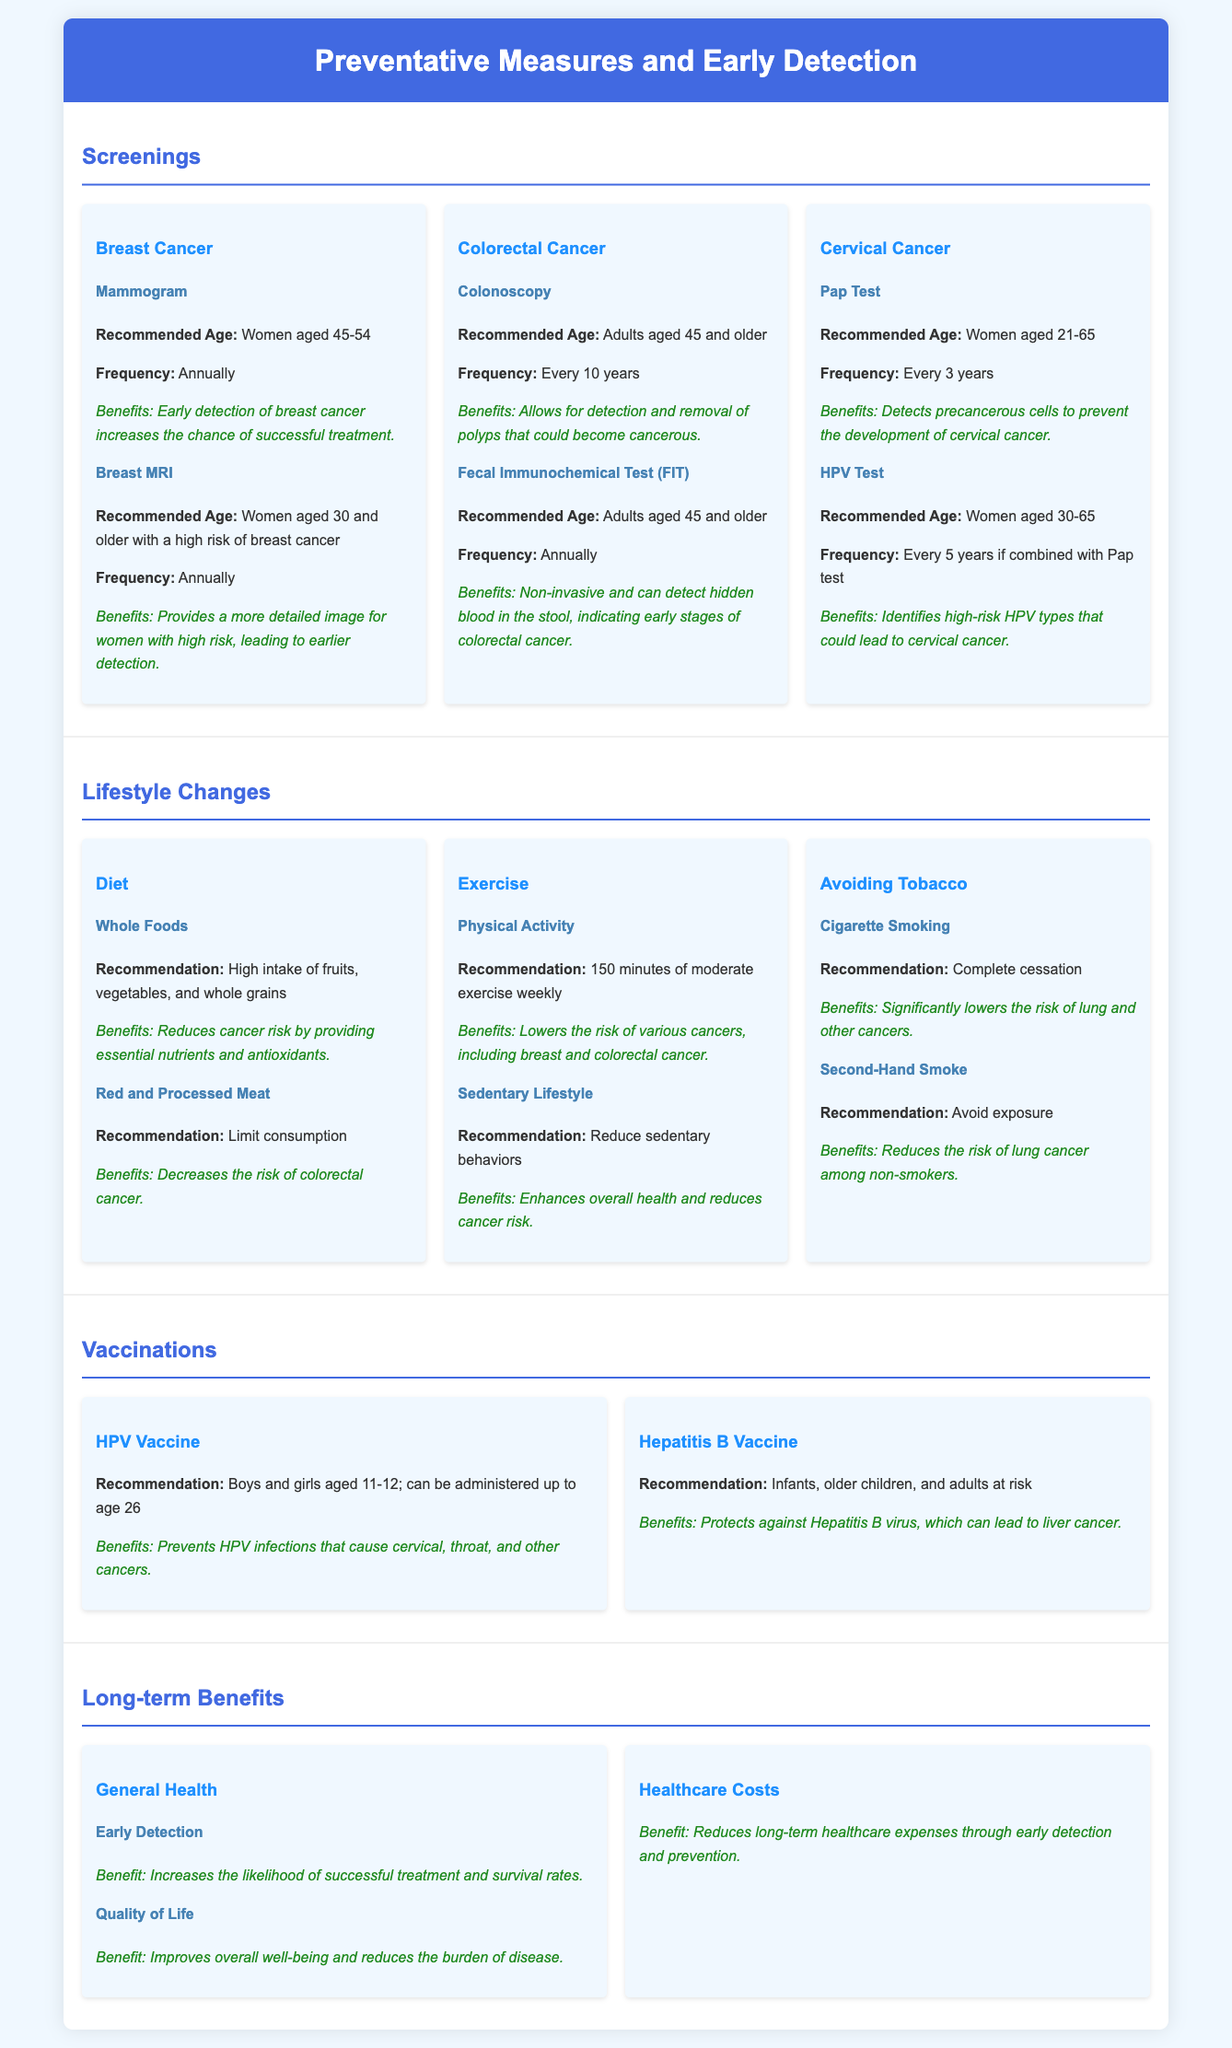What is the recommended age for a mammogram? The document states that women aged 45-54 should have a mammogram.
Answer: Women aged 45-54 How often should adults aged 45 and older have a colonoscopy? According to the document, adults aged 45 and older should have a colonoscopy every 10 years.
Answer: Every 10 years What is the benefit of early detection mentioned in the long-term benefits section? The benefit of early detection is an increased likelihood of successful treatment and survival rates.
Answer: Increased likelihood of successful treatment and survival rates What lifestyle change is recommended to limit the risk of colorectal cancer? The document advises to limit the consumption of red and processed meat to reduce the risk of colorectal cancer.
Answer: Limit consumption of red and processed meat What vaccination is recommended for boys and girls aged 11-12? The document recommends the HPV vaccine for boys and girls aged 11-12.
Answer: HPV vaccine What is stated as the frequency for a Pap test? The document mentions that women aged 21-65 should have a Pap test every 3 years.
Answer: Every 3 years What does the document suggest to enhance overall health? The document recommends reducing sedentary behaviors to enhance overall health.
Answer: Reduce sedentary behaviors What is the recommendation for physical activity according to the lifestyle changes section? The recommendation for physical activity is 150 minutes of moderate exercise weekly.
Answer: 150 minutes of moderate exercise weekly What is one benefit of avoiding second-hand smoke? The document states that avoiding second-hand smoke reduces the risk of lung cancer among non-smokers.
Answer: Reduces the risk of lung cancer among non-smokers 